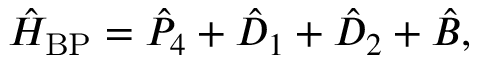<formula> <loc_0><loc_0><loc_500><loc_500>\begin{array} { r } { \hat { H } _ { B P } = \hat { P } _ { 4 } + \hat { D } _ { 1 } + \hat { D } _ { 2 } + \hat { B } , } \end{array}</formula> 